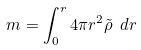Convert formula to latex. <formula><loc_0><loc_0><loc_500><loc_500>m = \int ^ { r } _ { 0 } 4 \pi r ^ { 2 } \tilde { \rho } \ d r</formula> 